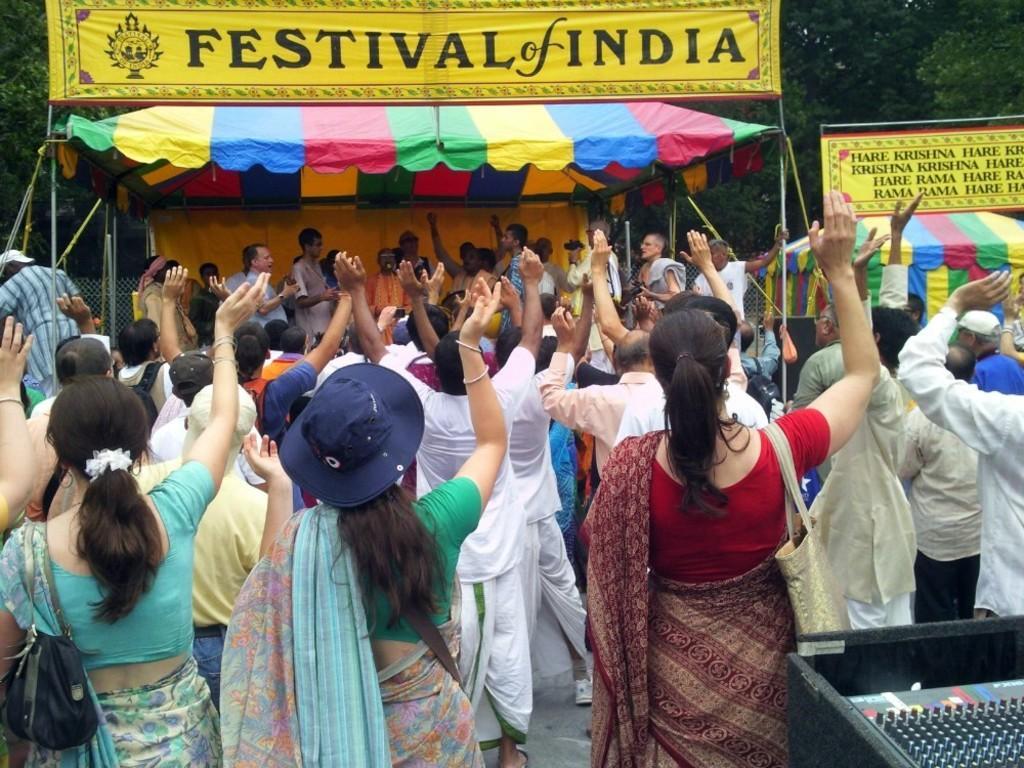Can you describe this image briefly? In front of the image there are people standing. On the right side of the image there is some object. In the background of the image there are banners, tents. There is a mesh. There are trees. 